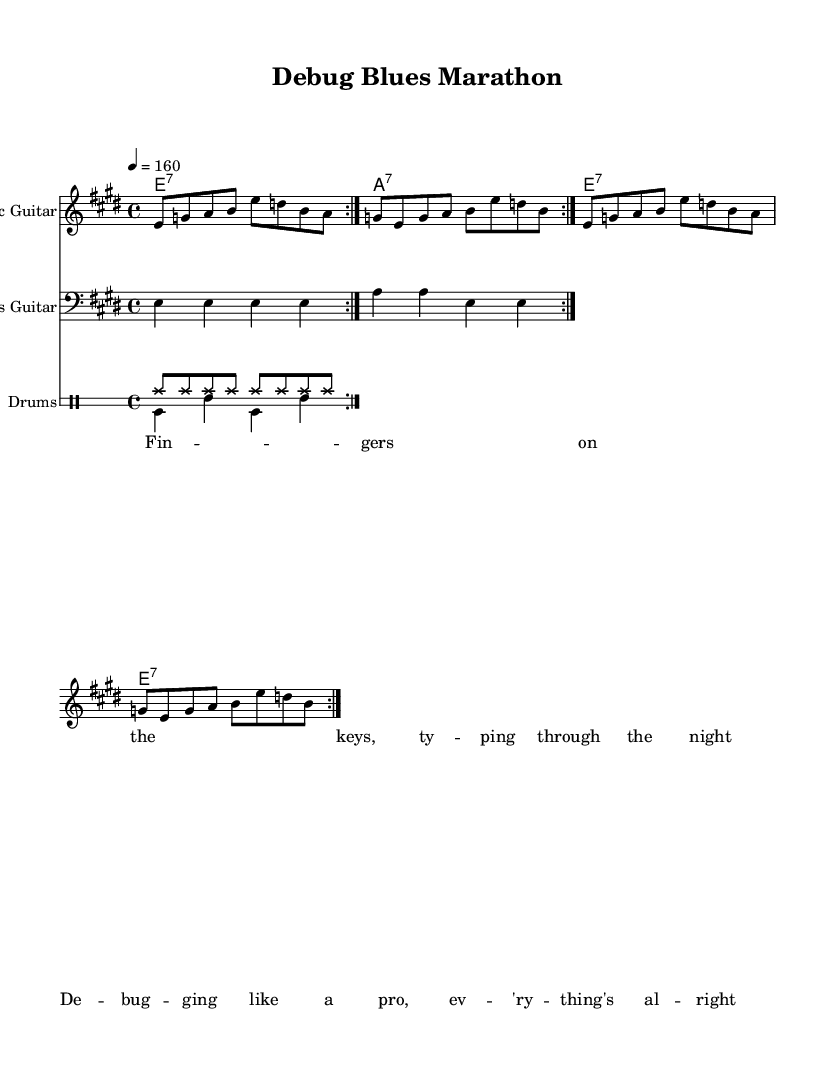What is the key signature of this music? The key signature is determined by looking at the number of sharps or flats in the piece. This piece has four sharps, which indicates it is in E major.
Answer: E major What is the time signature of this music? The time signature is found at the beginning of the sheet music. In this case, it is written as 4/4, indicating four beats per measure and a quarter note receives one beat.
Answer: 4/4 What is the tempo marking for this piece? The tempo marking is indicated in the header section of the music sheet. Here, it specifies a tempo of quarter note equals 160 beats per minute.
Answer: 160 How many times is the electric guitar part repeated in the section? The repeat signs indicate that the section of the electric guitar is meant to be played twice. The repeat volta appears twice in the music.
Answer: 2 What style of music is this piece representing? The music is labeled in the header and described through its instruments and sections, indicating it is an electric blues piece, which is characterized by its soulful and energetic rhythm.
Answer: Electric blues What type of drums are indicated in the sheet music? The sheet music specifies two types of drum patterns labeled as "drumsUp" and "drumsDown", indicating two separate drum rhythms used throughout the piece with specific notations for each.
Answer: Drums What lyrical theme is portrayed in the verse? The content of the verse reflects themes of coding and debugging challenges, indicating a connection to programming ideas and the experience of a coding marathon.
Answer: Coding and debugging 